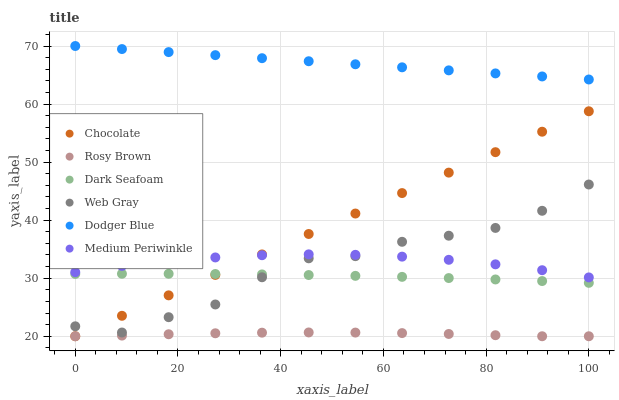Does Rosy Brown have the minimum area under the curve?
Answer yes or no. Yes. Does Dodger Blue have the maximum area under the curve?
Answer yes or no. Yes. Does Medium Periwinkle have the minimum area under the curve?
Answer yes or no. No. Does Medium Periwinkle have the maximum area under the curve?
Answer yes or no. No. Is Chocolate the smoothest?
Answer yes or no. Yes. Is Web Gray the roughest?
Answer yes or no. Yes. Is Rosy Brown the smoothest?
Answer yes or no. No. Is Rosy Brown the roughest?
Answer yes or no. No. Does Rosy Brown have the lowest value?
Answer yes or no. Yes. Does Medium Periwinkle have the lowest value?
Answer yes or no. No. Does Dodger Blue have the highest value?
Answer yes or no. Yes. Does Medium Periwinkle have the highest value?
Answer yes or no. No. Is Rosy Brown less than Medium Periwinkle?
Answer yes or no. Yes. Is Dodger Blue greater than Dark Seafoam?
Answer yes or no. Yes. Does Chocolate intersect Dark Seafoam?
Answer yes or no. Yes. Is Chocolate less than Dark Seafoam?
Answer yes or no. No. Is Chocolate greater than Dark Seafoam?
Answer yes or no. No. Does Rosy Brown intersect Medium Periwinkle?
Answer yes or no. No. 